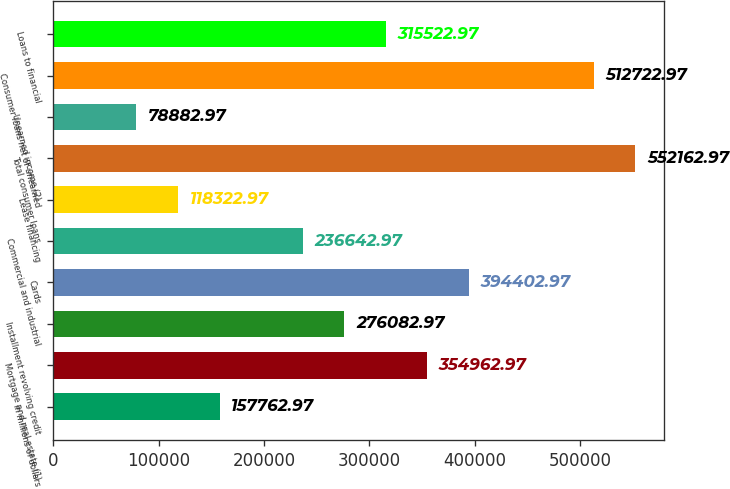Convert chart. <chart><loc_0><loc_0><loc_500><loc_500><bar_chart><fcel>In millions of dollars<fcel>Mortgage and real estate (1)<fcel>Installment revolving credit<fcel>Cards<fcel>Commercial and industrial<fcel>Lease financing<fcel>Total consumer loans<fcel>Unearned income (2)<fcel>Consumer loans net of unearned<fcel>Loans to financial<nl><fcel>157763<fcel>354963<fcel>276083<fcel>394403<fcel>236643<fcel>118323<fcel>552163<fcel>78883<fcel>512723<fcel>315523<nl></chart> 